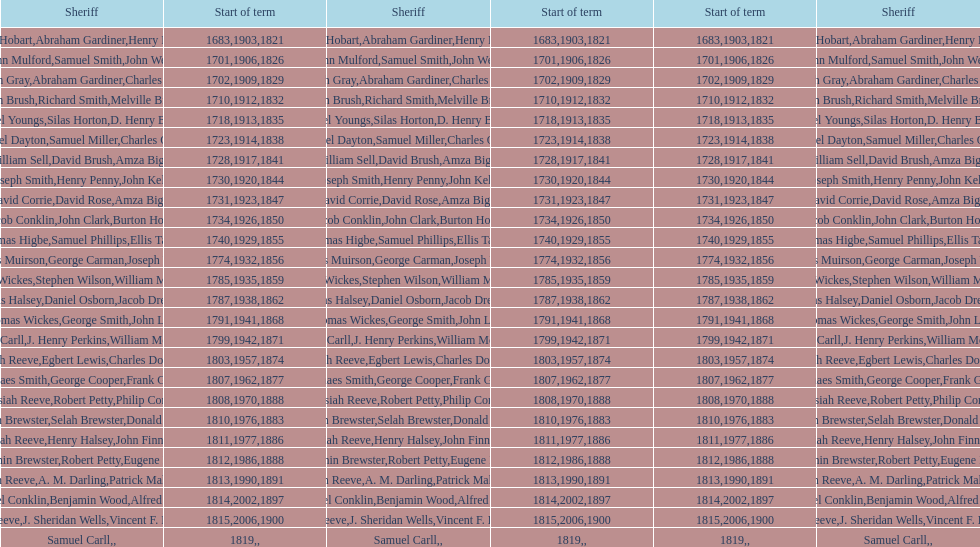How sheriffs has suffolk county had in total? 76. 